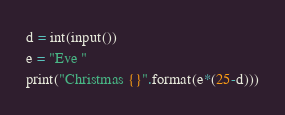<code> <loc_0><loc_0><loc_500><loc_500><_Python_>
d = int(input())
e = "Eve "
print("Christmas {}".format(e*(25-d)))</code> 